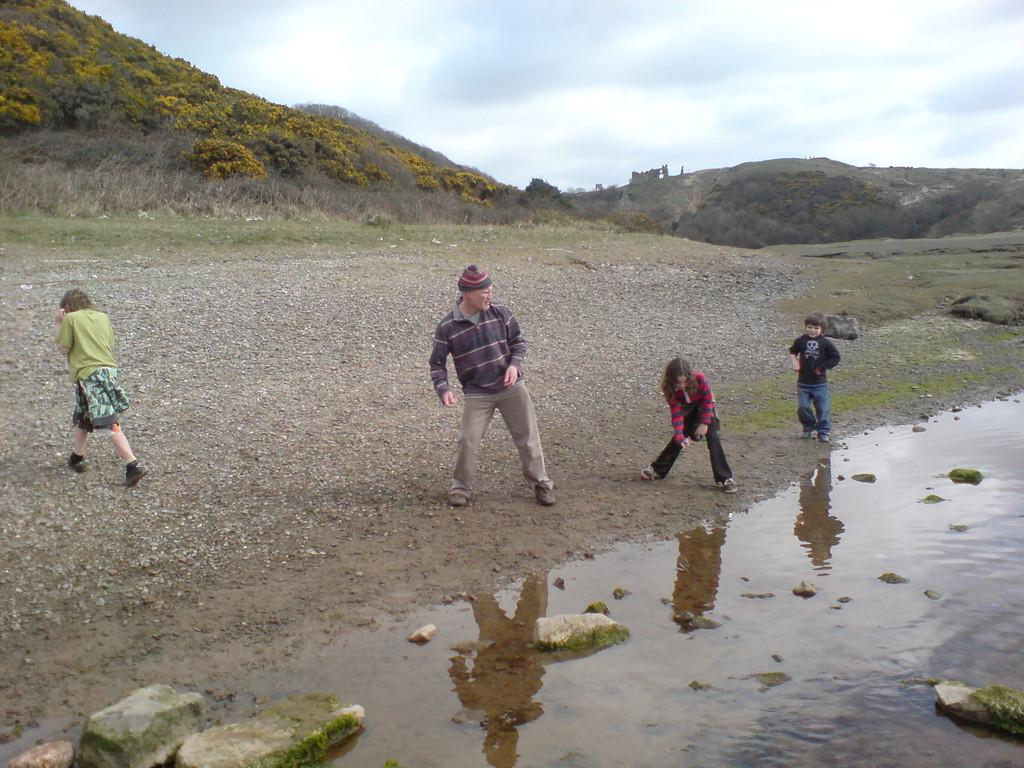How many people are in the image? There are four people standing in the image. What is the natural feature visible in the image? The image appears to depict hills. What type of vegetation can be seen in the image? Trees and bushes are visible in the image. What is visible in the background of the image? The sky is visible in the image. What type of prison can be seen in the image? There is no prison present in the image; it depicts a natural landscape with hills, trees, bushes, and people. What type of fowl is visible in the image? There is no fowl present in the image; it features a natural landscape with hills, trees, bushes, and people. 